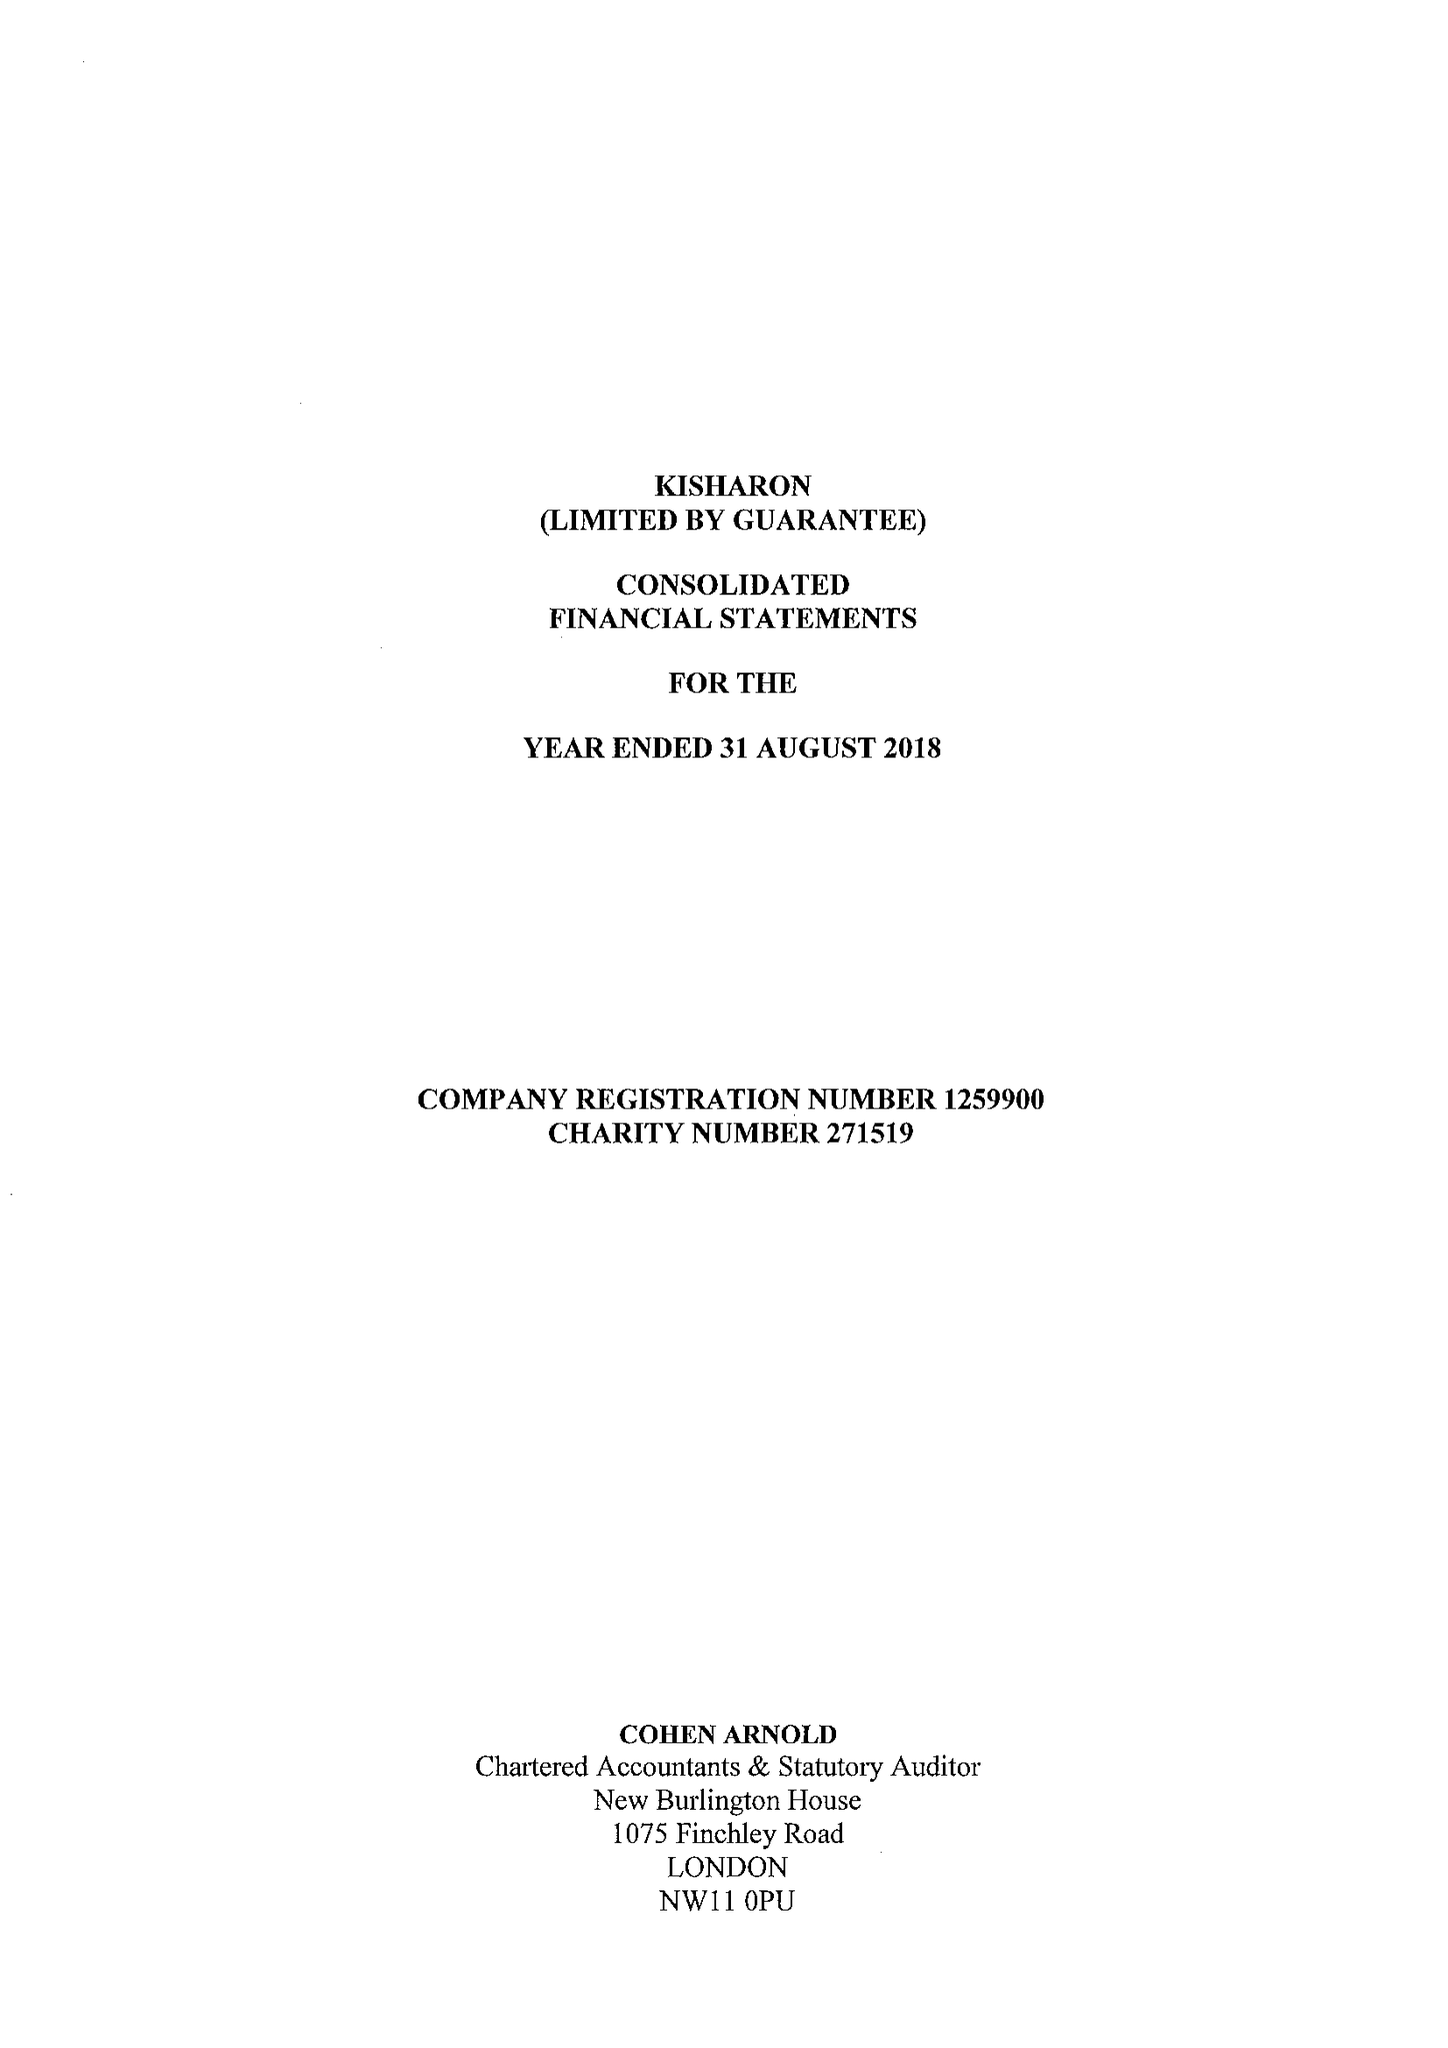What is the value for the address__postcode?
Answer the question using a single word or phrase. NW9 6TD 